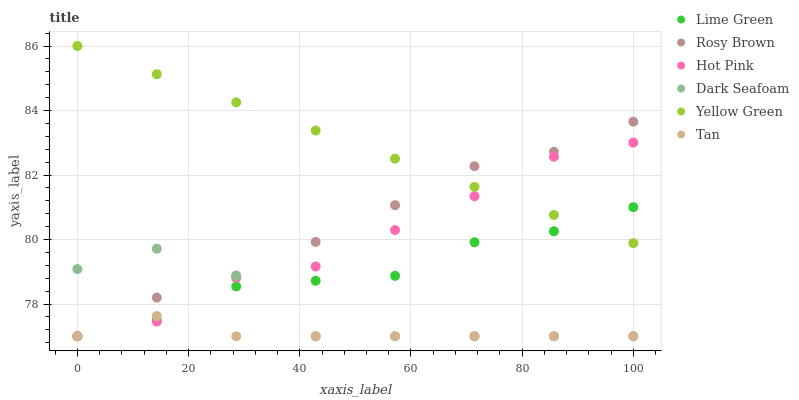Does Tan have the minimum area under the curve?
Answer yes or no. Yes. Does Yellow Green have the maximum area under the curve?
Answer yes or no. Yes. Does Rosy Brown have the minimum area under the curve?
Answer yes or no. No. Does Rosy Brown have the maximum area under the curve?
Answer yes or no. No. Is Yellow Green the smoothest?
Answer yes or no. Yes. Is Dark Seafoam the roughest?
Answer yes or no. Yes. Is Rosy Brown the smoothest?
Answer yes or no. No. Is Rosy Brown the roughest?
Answer yes or no. No. Does Hot Pink have the lowest value?
Answer yes or no. Yes. Does Yellow Green have the lowest value?
Answer yes or no. No. Does Yellow Green have the highest value?
Answer yes or no. Yes. Does Rosy Brown have the highest value?
Answer yes or no. No. Is Dark Seafoam less than Yellow Green?
Answer yes or no. Yes. Is Yellow Green greater than Tan?
Answer yes or no. Yes. Does Rosy Brown intersect Hot Pink?
Answer yes or no. Yes. Is Rosy Brown less than Hot Pink?
Answer yes or no. No. Is Rosy Brown greater than Hot Pink?
Answer yes or no. No. Does Dark Seafoam intersect Yellow Green?
Answer yes or no. No. 